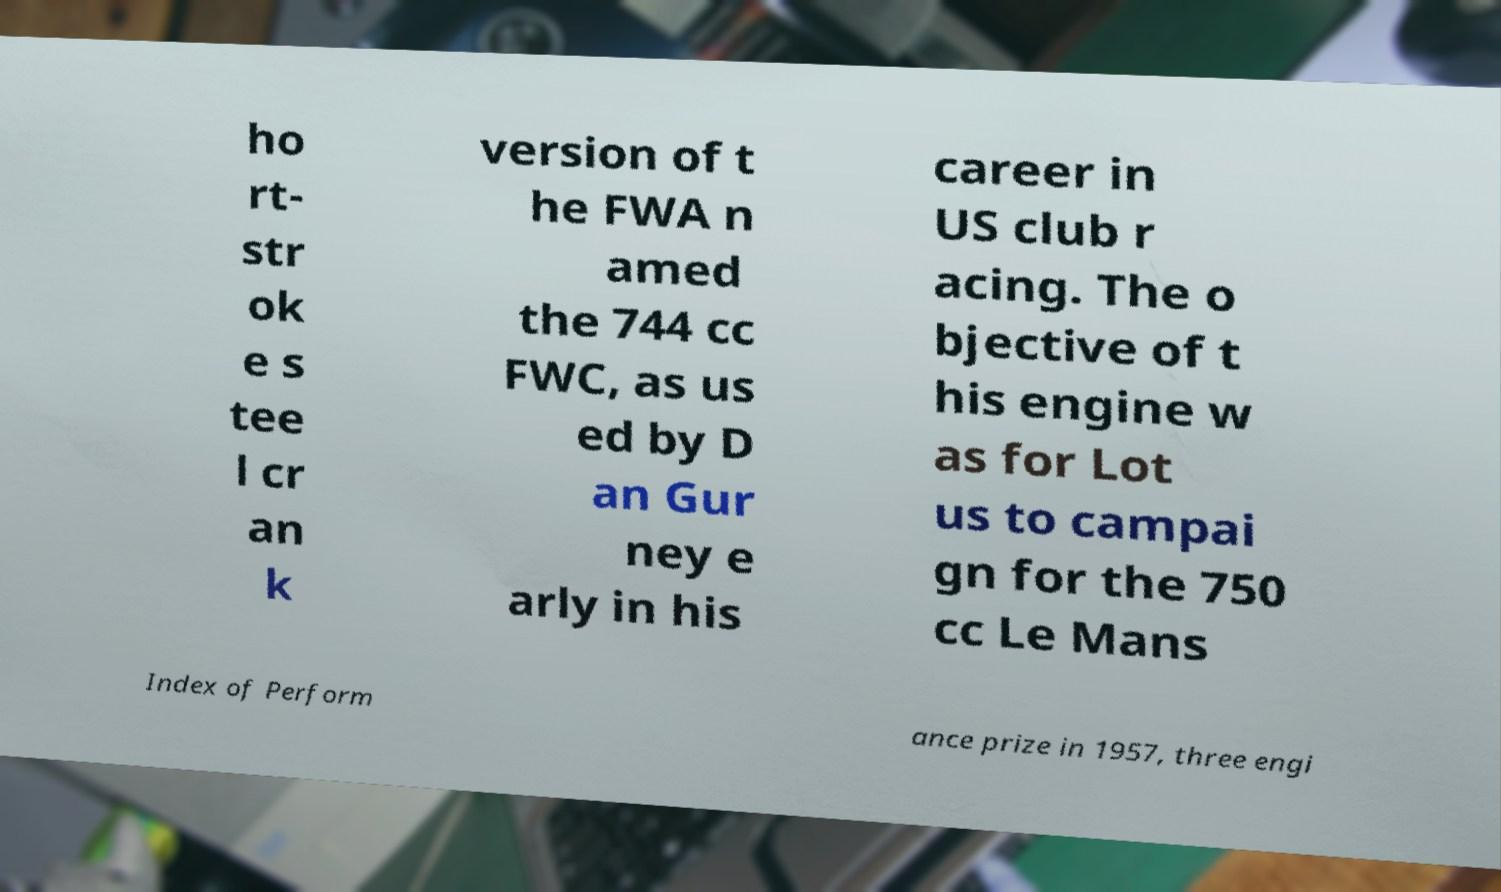Please read and relay the text visible in this image. What does it say? ho rt- str ok e s tee l cr an k version of t he FWA n amed the 744 cc FWC, as us ed by D an Gur ney e arly in his career in US club r acing. The o bjective of t his engine w as for Lot us to campai gn for the 750 cc Le Mans Index of Perform ance prize in 1957, three engi 